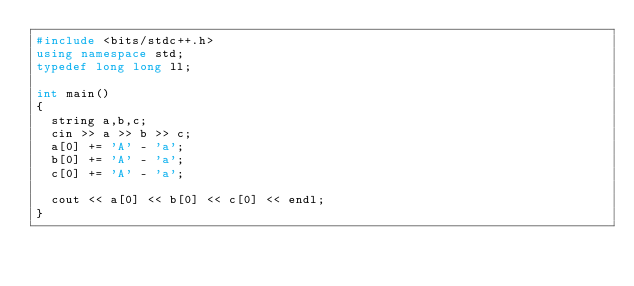<code> <loc_0><loc_0><loc_500><loc_500><_C++_>#include <bits/stdc++.h>
using namespace std;
typedef long long ll;

int main()
{
  string a,b,c;
  cin >> a >> b >> c;
  a[0] += 'A' - 'a';
  b[0] += 'A' - 'a';
  c[0] += 'A' - 'a';

  cout << a[0] << b[0] << c[0] << endl;
}
</code> 